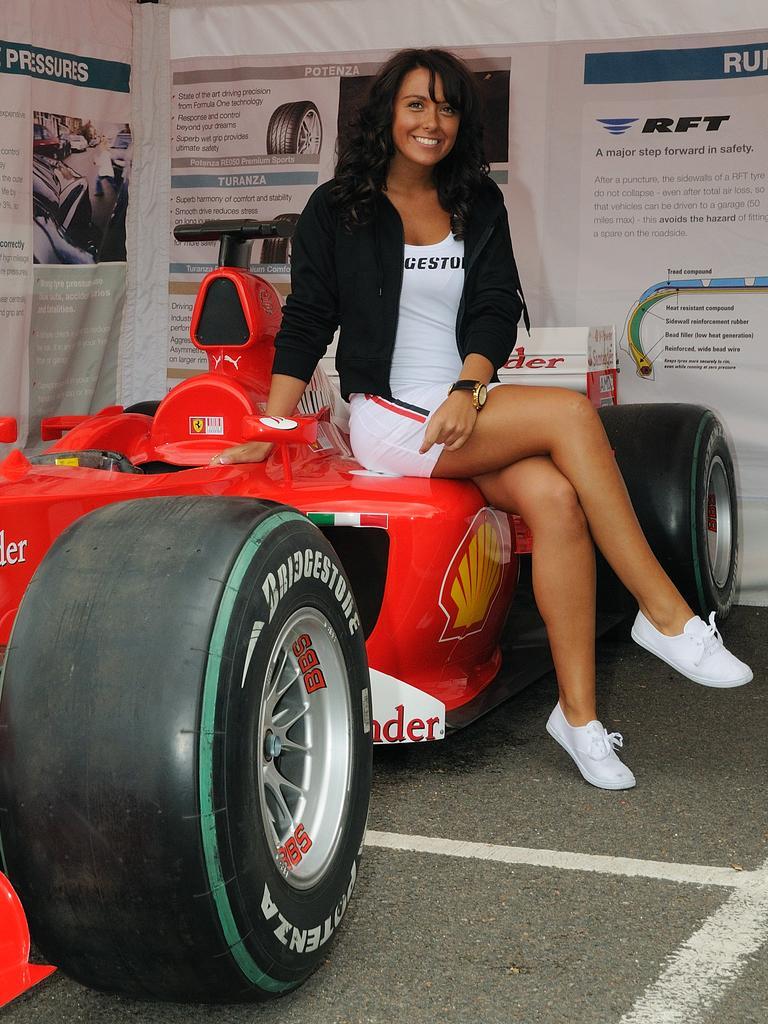Please provide a concise description of this image. In this image, there is a person wearing clothes and sitting on the car. 